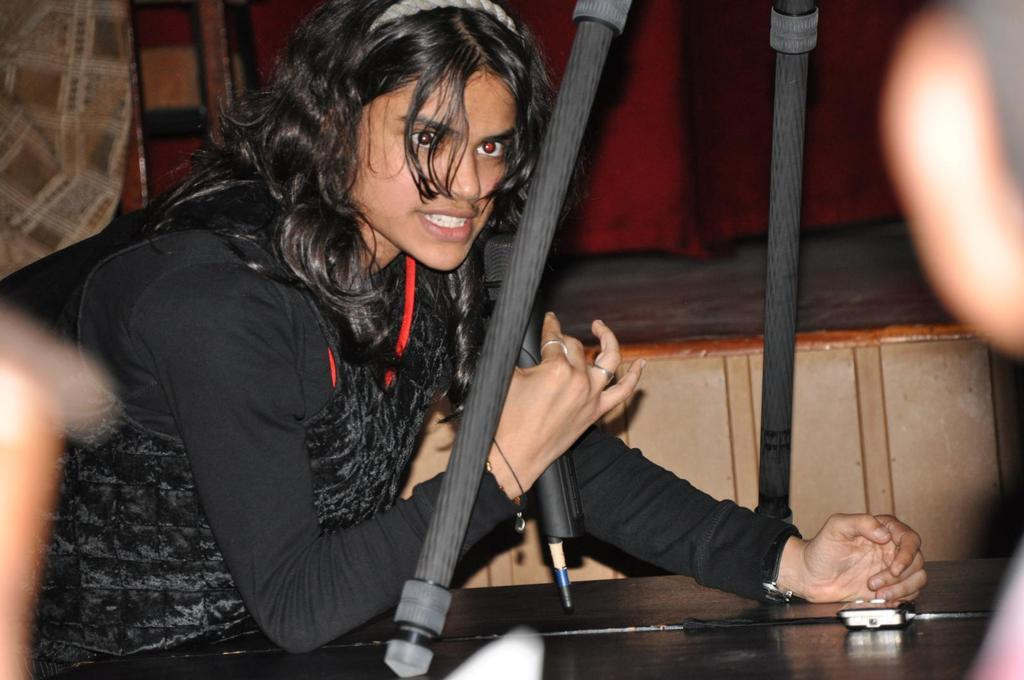What can be seen in the image? There is a person in the image. What is the person wearing? The person is wearing a black dress. What is the person holding? The person is holding a mic. What else can be seen around the person? There are objects visible around the person. How many goldfish are swimming in the background of the image? There are no goldfish present in the image. What type of beef is being served on a plate in the image? There is no beef present in the image. 